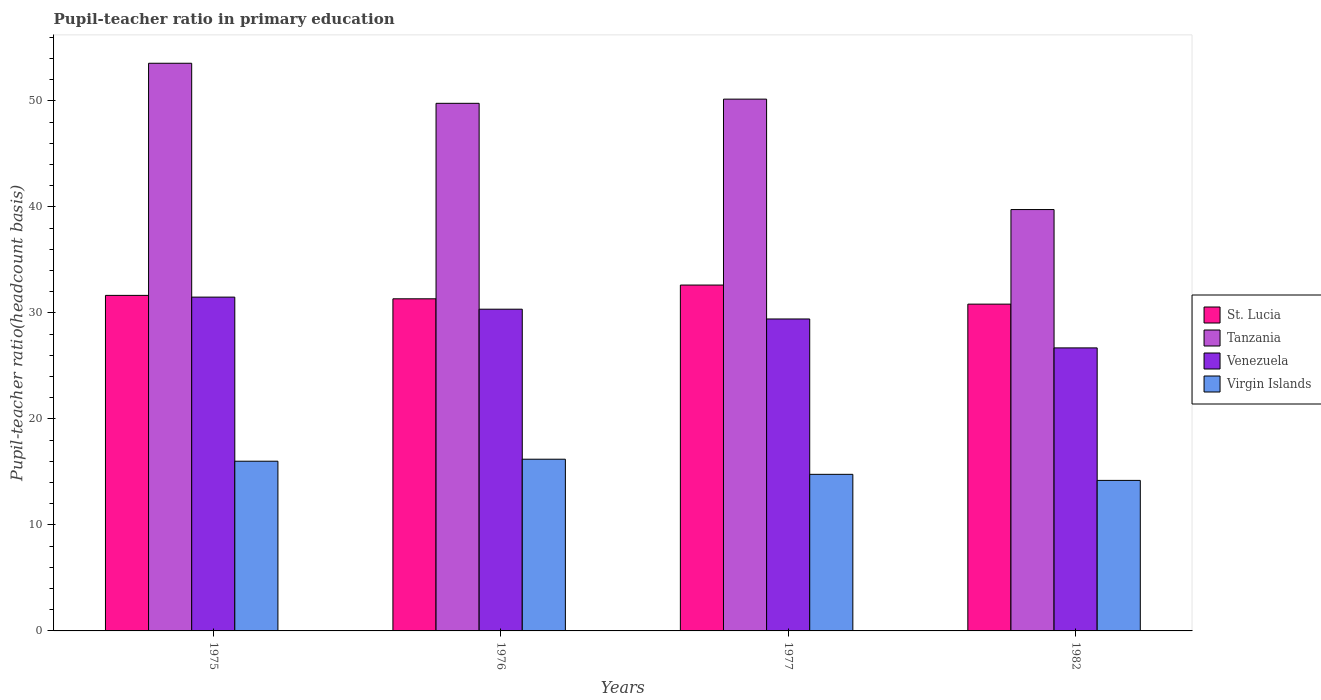How many groups of bars are there?
Ensure brevity in your answer.  4. Are the number of bars per tick equal to the number of legend labels?
Your answer should be very brief. Yes. How many bars are there on the 2nd tick from the right?
Ensure brevity in your answer.  4. What is the label of the 4th group of bars from the left?
Provide a short and direct response. 1982. In how many cases, is the number of bars for a given year not equal to the number of legend labels?
Give a very brief answer. 0. What is the pupil-teacher ratio in primary education in Virgin Islands in 1976?
Ensure brevity in your answer.  16.2. Across all years, what is the maximum pupil-teacher ratio in primary education in St. Lucia?
Offer a very short reply. 32.63. Across all years, what is the minimum pupil-teacher ratio in primary education in St. Lucia?
Offer a terse response. 30.83. In which year was the pupil-teacher ratio in primary education in Venezuela maximum?
Offer a terse response. 1975. What is the total pupil-teacher ratio in primary education in Tanzania in the graph?
Your answer should be compact. 193.25. What is the difference between the pupil-teacher ratio in primary education in Virgin Islands in 1977 and that in 1982?
Give a very brief answer. 0.57. What is the difference between the pupil-teacher ratio in primary education in Tanzania in 1975 and the pupil-teacher ratio in primary education in St. Lucia in 1977?
Your answer should be very brief. 20.92. What is the average pupil-teacher ratio in primary education in Tanzania per year?
Provide a succinct answer. 48.31. In the year 1976, what is the difference between the pupil-teacher ratio in primary education in Virgin Islands and pupil-teacher ratio in primary education in Venezuela?
Your answer should be compact. -14.15. What is the ratio of the pupil-teacher ratio in primary education in Tanzania in 1977 to that in 1982?
Offer a terse response. 1.26. Is the difference between the pupil-teacher ratio in primary education in Virgin Islands in 1975 and 1977 greater than the difference between the pupil-teacher ratio in primary education in Venezuela in 1975 and 1977?
Make the answer very short. No. What is the difference between the highest and the second highest pupil-teacher ratio in primary education in Tanzania?
Keep it short and to the point. 3.38. What is the difference between the highest and the lowest pupil-teacher ratio in primary education in Tanzania?
Your response must be concise. 13.8. What does the 2nd bar from the left in 1977 represents?
Offer a terse response. Tanzania. What does the 2nd bar from the right in 1977 represents?
Provide a short and direct response. Venezuela. Is it the case that in every year, the sum of the pupil-teacher ratio in primary education in Virgin Islands and pupil-teacher ratio in primary education in Tanzania is greater than the pupil-teacher ratio in primary education in Venezuela?
Your response must be concise. Yes. How many bars are there?
Make the answer very short. 16. Are all the bars in the graph horizontal?
Provide a succinct answer. No. How many years are there in the graph?
Your answer should be very brief. 4. What is the difference between two consecutive major ticks on the Y-axis?
Your response must be concise. 10. Are the values on the major ticks of Y-axis written in scientific E-notation?
Keep it short and to the point. No. Does the graph contain any zero values?
Offer a very short reply. No. How many legend labels are there?
Offer a terse response. 4. What is the title of the graph?
Provide a short and direct response. Pupil-teacher ratio in primary education. What is the label or title of the Y-axis?
Your answer should be compact. Pupil-teacher ratio(headcount basis). What is the Pupil-teacher ratio(headcount basis) of St. Lucia in 1975?
Your answer should be very brief. 31.65. What is the Pupil-teacher ratio(headcount basis) of Tanzania in 1975?
Your answer should be compact. 53.55. What is the Pupil-teacher ratio(headcount basis) in Venezuela in 1975?
Ensure brevity in your answer.  31.49. What is the Pupil-teacher ratio(headcount basis) in Virgin Islands in 1975?
Provide a succinct answer. 16.01. What is the Pupil-teacher ratio(headcount basis) of St. Lucia in 1976?
Keep it short and to the point. 31.33. What is the Pupil-teacher ratio(headcount basis) in Tanzania in 1976?
Provide a succinct answer. 49.77. What is the Pupil-teacher ratio(headcount basis) of Venezuela in 1976?
Your answer should be compact. 30.35. What is the Pupil-teacher ratio(headcount basis) of Virgin Islands in 1976?
Offer a terse response. 16.2. What is the Pupil-teacher ratio(headcount basis) of St. Lucia in 1977?
Your answer should be compact. 32.63. What is the Pupil-teacher ratio(headcount basis) of Tanzania in 1977?
Ensure brevity in your answer.  50.17. What is the Pupil-teacher ratio(headcount basis) of Venezuela in 1977?
Provide a short and direct response. 29.43. What is the Pupil-teacher ratio(headcount basis) of Virgin Islands in 1977?
Ensure brevity in your answer.  14.77. What is the Pupil-teacher ratio(headcount basis) of St. Lucia in 1982?
Give a very brief answer. 30.83. What is the Pupil-teacher ratio(headcount basis) of Tanzania in 1982?
Your answer should be very brief. 39.75. What is the Pupil-teacher ratio(headcount basis) of Venezuela in 1982?
Provide a succinct answer. 26.7. Across all years, what is the maximum Pupil-teacher ratio(headcount basis) of St. Lucia?
Ensure brevity in your answer.  32.63. Across all years, what is the maximum Pupil-teacher ratio(headcount basis) in Tanzania?
Ensure brevity in your answer.  53.55. Across all years, what is the maximum Pupil-teacher ratio(headcount basis) of Venezuela?
Offer a terse response. 31.49. Across all years, what is the maximum Pupil-teacher ratio(headcount basis) in Virgin Islands?
Offer a terse response. 16.2. Across all years, what is the minimum Pupil-teacher ratio(headcount basis) in St. Lucia?
Ensure brevity in your answer.  30.83. Across all years, what is the minimum Pupil-teacher ratio(headcount basis) in Tanzania?
Ensure brevity in your answer.  39.75. Across all years, what is the minimum Pupil-teacher ratio(headcount basis) in Venezuela?
Keep it short and to the point. 26.7. Across all years, what is the minimum Pupil-teacher ratio(headcount basis) in Virgin Islands?
Provide a short and direct response. 14.2. What is the total Pupil-teacher ratio(headcount basis) in St. Lucia in the graph?
Keep it short and to the point. 126.44. What is the total Pupil-teacher ratio(headcount basis) in Tanzania in the graph?
Give a very brief answer. 193.25. What is the total Pupil-teacher ratio(headcount basis) in Venezuela in the graph?
Provide a succinct answer. 117.97. What is the total Pupil-teacher ratio(headcount basis) of Virgin Islands in the graph?
Your answer should be very brief. 61.18. What is the difference between the Pupil-teacher ratio(headcount basis) of St. Lucia in 1975 and that in 1976?
Provide a short and direct response. 0.32. What is the difference between the Pupil-teacher ratio(headcount basis) of Tanzania in 1975 and that in 1976?
Make the answer very short. 3.78. What is the difference between the Pupil-teacher ratio(headcount basis) of Venezuela in 1975 and that in 1976?
Your answer should be compact. 1.14. What is the difference between the Pupil-teacher ratio(headcount basis) of Virgin Islands in 1975 and that in 1976?
Offer a very short reply. -0.19. What is the difference between the Pupil-teacher ratio(headcount basis) in St. Lucia in 1975 and that in 1977?
Offer a terse response. -0.97. What is the difference between the Pupil-teacher ratio(headcount basis) in Tanzania in 1975 and that in 1977?
Keep it short and to the point. 3.38. What is the difference between the Pupil-teacher ratio(headcount basis) in Venezuela in 1975 and that in 1977?
Keep it short and to the point. 2.06. What is the difference between the Pupil-teacher ratio(headcount basis) of Virgin Islands in 1975 and that in 1977?
Your answer should be very brief. 1.24. What is the difference between the Pupil-teacher ratio(headcount basis) of St. Lucia in 1975 and that in 1982?
Make the answer very short. 0.82. What is the difference between the Pupil-teacher ratio(headcount basis) of Tanzania in 1975 and that in 1982?
Provide a succinct answer. 13.8. What is the difference between the Pupil-teacher ratio(headcount basis) of Venezuela in 1975 and that in 1982?
Offer a very short reply. 4.79. What is the difference between the Pupil-teacher ratio(headcount basis) of Virgin Islands in 1975 and that in 1982?
Provide a short and direct response. 1.81. What is the difference between the Pupil-teacher ratio(headcount basis) in St. Lucia in 1976 and that in 1977?
Your response must be concise. -1.3. What is the difference between the Pupil-teacher ratio(headcount basis) of Tanzania in 1976 and that in 1977?
Make the answer very short. -0.4. What is the difference between the Pupil-teacher ratio(headcount basis) of Venezuela in 1976 and that in 1977?
Your response must be concise. 0.92. What is the difference between the Pupil-teacher ratio(headcount basis) in Virgin Islands in 1976 and that in 1977?
Your answer should be compact. 1.43. What is the difference between the Pupil-teacher ratio(headcount basis) in St. Lucia in 1976 and that in 1982?
Your response must be concise. 0.5. What is the difference between the Pupil-teacher ratio(headcount basis) in Tanzania in 1976 and that in 1982?
Your response must be concise. 10.02. What is the difference between the Pupil-teacher ratio(headcount basis) in Venezuela in 1976 and that in 1982?
Ensure brevity in your answer.  3.65. What is the difference between the Pupil-teacher ratio(headcount basis) of Virgin Islands in 1976 and that in 1982?
Give a very brief answer. 2. What is the difference between the Pupil-teacher ratio(headcount basis) of St. Lucia in 1977 and that in 1982?
Your answer should be compact. 1.8. What is the difference between the Pupil-teacher ratio(headcount basis) in Tanzania in 1977 and that in 1982?
Provide a succinct answer. 10.42. What is the difference between the Pupil-teacher ratio(headcount basis) in Venezuela in 1977 and that in 1982?
Give a very brief answer. 2.73. What is the difference between the Pupil-teacher ratio(headcount basis) in Virgin Islands in 1977 and that in 1982?
Offer a terse response. 0.57. What is the difference between the Pupil-teacher ratio(headcount basis) in St. Lucia in 1975 and the Pupil-teacher ratio(headcount basis) in Tanzania in 1976?
Ensure brevity in your answer.  -18.12. What is the difference between the Pupil-teacher ratio(headcount basis) of St. Lucia in 1975 and the Pupil-teacher ratio(headcount basis) of Venezuela in 1976?
Your response must be concise. 1.3. What is the difference between the Pupil-teacher ratio(headcount basis) in St. Lucia in 1975 and the Pupil-teacher ratio(headcount basis) in Virgin Islands in 1976?
Keep it short and to the point. 15.46. What is the difference between the Pupil-teacher ratio(headcount basis) in Tanzania in 1975 and the Pupil-teacher ratio(headcount basis) in Venezuela in 1976?
Keep it short and to the point. 23.2. What is the difference between the Pupil-teacher ratio(headcount basis) in Tanzania in 1975 and the Pupil-teacher ratio(headcount basis) in Virgin Islands in 1976?
Your answer should be very brief. 37.35. What is the difference between the Pupil-teacher ratio(headcount basis) in Venezuela in 1975 and the Pupil-teacher ratio(headcount basis) in Virgin Islands in 1976?
Your answer should be very brief. 15.29. What is the difference between the Pupil-teacher ratio(headcount basis) of St. Lucia in 1975 and the Pupil-teacher ratio(headcount basis) of Tanzania in 1977?
Ensure brevity in your answer.  -18.52. What is the difference between the Pupil-teacher ratio(headcount basis) in St. Lucia in 1975 and the Pupil-teacher ratio(headcount basis) in Venezuela in 1977?
Your answer should be compact. 2.23. What is the difference between the Pupil-teacher ratio(headcount basis) in St. Lucia in 1975 and the Pupil-teacher ratio(headcount basis) in Virgin Islands in 1977?
Offer a very short reply. 16.88. What is the difference between the Pupil-teacher ratio(headcount basis) of Tanzania in 1975 and the Pupil-teacher ratio(headcount basis) of Venezuela in 1977?
Make the answer very short. 24.12. What is the difference between the Pupil-teacher ratio(headcount basis) of Tanzania in 1975 and the Pupil-teacher ratio(headcount basis) of Virgin Islands in 1977?
Provide a succinct answer. 38.78. What is the difference between the Pupil-teacher ratio(headcount basis) of Venezuela in 1975 and the Pupil-teacher ratio(headcount basis) of Virgin Islands in 1977?
Provide a succinct answer. 16.72. What is the difference between the Pupil-teacher ratio(headcount basis) in St. Lucia in 1975 and the Pupil-teacher ratio(headcount basis) in Tanzania in 1982?
Provide a succinct answer. -8.1. What is the difference between the Pupil-teacher ratio(headcount basis) in St. Lucia in 1975 and the Pupil-teacher ratio(headcount basis) in Venezuela in 1982?
Ensure brevity in your answer.  4.95. What is the difference between the Pupil-teacher ratio(headcount basis) in St. Lucia in 1975 and the Pupil-teacher ratio(headcount basis) in Virgin Islands in 1982?
Offer a terse response. 17.45. What is the difference between the Pupil-teacher ratio(headcount basis) in Tanzania in 1975 and the Pupil-teacher ratio(headcount basis) in Venezuela in 1982?
Offer a very short reply. 26.85. What is the difference between the Pupil-teacher ratio(headcount basis) of Tanzania in 1975 and the Pupil-teacher ratio(headcount basis) of Virgin Islands in 1982?
Offer a terse response. 39.35. What is the difference between the Pupil-teacher ratio(headcount basis) of Venezuela in 1975 and the Pupil-teacher ratio(headcount basis) of Virgin Islands in 1982?
Ensure brevity in your answer.  17.29. What is the difference between the Pupil-teacher ratio(headcount basis) in St. Lucia in 1976 and the Pupil-teacher ratio(headcount basis) in Tanzania in 1977?
Make the answer very short. -18.84. What is the difference between the Pupil-teacher ratio(headcount basis) in St. Lucia in 1976 and the Pupil-teacher ratio(headcount basis) in Venezuela in 1977?
Ensure brevity in your answer.  1.9. What is the difference between the Pupil-teacher ratio(headcount basis) of St. Lucia in 1976 and the Pupil-teacher ratio(headcount basis) of Virgin Islands in 1977?
Keep it short and to the point. 16.56. What is the difference between the Pupil-teacher ratio(headcount basis) of Tanzania in 1976 and the Pupil-teacher ratio(headcount basis) of Venezuela in 1977?
Your answer should be compact. 20.34. What is the difference between the Pupil-teacher ratio(headcount basis) of Tanzania in 1976 and the Pupil-teacher ratio(headcount basis) of Virgin Islands in 1977?
Keep it short and to the point. 35. What is the difference between the Pupil-teacher ratio(headcount basis) in Venezuela in 1976 and the Pupil-teacher ratio(headcount basis) in Virgin Islands in 1977?
Give a very brief answer. 15.58. What is the difference between the Pupil-teacher ratio(headcount basis) of St. Lucia in 1976 and the Pupil-teacher ratio(headcount basis) of Tanzania in 1982?
Offer a terse response. -8.42. What is the difference between the Pupil-teacher ratio(headcount basis) of St. Lucia in 1976 and the Pupil-teacher ratio(headcount basis) of Venezuela in 1982?
Give a very brief answer. 4.63. What is the difference between the Pupil-teacher ratio(headcount basis) of St. Lucia in 1976 and the Pupil-teacher ratio(headcount basis) of Virgin Islands in 1982?
Your response must be concise. 17.13. What is the difference between the Pupil-teacher ratio(headcount basis) of Tanzania in 1976 and the Pupil-teacher ratio(headcount basis) of Venezuela in 1982?
Give a very brief answer. 23.07. What is the difference between the Pupil-teacher ratio(headcount basis) of Tanzania in 1976 and the Pupil-teacher ratio(headcount basis) of Virgin Islands in 1982?
Offer a very short reply. 35.57. What is the difference between the Pupil-teacher ratio(headcount basis) of Venezuela in 1976 and the Pupil-teacher ratio(headcount basis) of Virgin Islands in 1982?
Provide a short and direct response. 16.15. What is the difference between the Pupil-teacher ratio(headcount basis) in St. Lucia in 1977 and the Pupil-teacher ratio(headcount basis) in Tanzania in 1982?
Provide a succinct answer. -7.12. What is the difference between the Pupil-teacher ratio(headcount basis) of St. Lucia in 1977 and the Pupil-teacher ratio(headcount basis) of Venezuela in 1982?
Offer a terse response. 5.93. What is the difference between the Pupil-teacher ratio(headcount basis) of St. Lucia in 1977 and the Pupil-teacher ratio(headcount basis) of Virgin Islands in 1982?
Your answer should be compact. 18.43. What is the difference between the Pupil-teacher ratio(headcount basis) of Tanzania in 1977 and the Pupil-teacher ratio(headcount basis) of Venezuela in 1982?
Your answer should be very brief. 23.47. What is the difference between the Pupil-teacher ratio(headcount basis) in Tanzania in 1977 and the Pupil-teacher ratio(headcount basis) in Virgin Islands in 1982?
Keep it short and to the point. 35.97. What is the difference between the Pupil-teacher ratio(headcount basis) in Venezuela in 1977 and the Pupil-teacher ratio(headcount basis) in Virgin Islands in 1982?
Offer a very short reply. 15.23. What is the average Pupil-teacher ratio(headcount basis) in St. Lucia per year?
Offer a very short reply. 31.61. What is the average Pupil-teacher ratio(headcount basis) in Tanzania per year?
Offer a very short reply. 48.31. What is the average Pupil-teacher ratio(headcount basis) of Venezuela per year?
Your answer should be very brief. 29.49. What is the average Pupil-teacher ratio(headcount basis) of Virgin Islands per year?
Your answer should be very brief. 15.3. In the year 1975, what is the difference between the Pupil-teacher ratio(headcount basis) of St. Lucia and Pupil-teacher ratio(headcount basis) of Tanzania?
Make the answer very short. -21.9. In the year 1975, what is the difference between the Pupil-teacher ratio(headcount basis) in St. Lucia and Pupil-teacher ratio(headcount basis) in Venezuela?
Provide a succinct answer. 0.16. In the year 1975, what is the difference between the Pupil-teacher ratio(headcount basis) of St. Lucia and Pupil-teacher ratio(headcount basis) of Virgin Islands?
Provide a succinct answer. 15.64. In the year 1975, what is the difference between the Pupil-teacher ratio(headcount basis) in Tanzania and Pupil-teacher ratio(headcount basis) in Venezuela?
Offer a terse response. 22.06. In the year 1975, what is the difference between the Pupil-teacher ratio(headcount basis) in Tanzania and Pupil-teacher ratio(headcount basis) in Virgin Islands?
Provide a succinct answer. 37.54. In the year 1975, what is the difference between the Pupil-teacher ratio(headcount basis) in Venezuela and Pupil-teacher ratio(headcount basis) in Virgin Islands?
Your response must be concise. 15.48. In the year 1976, what is the difference between the Pupil-teacher ratio(headcount basis) in St. Lucia and Pupil-teacher ratio(headcount basis) in Tanzania?
Provide a short and direct response. -18.44. In the year 1976, what is the difference between the Pupil-teacher ratio(headcount basis) of St. Lucia and Pupil-teacher ratio(headcount basis) of Venezuela?
Provide a short and direct response. 0.98. In the year 1976, what is the difference between the Pupil-teacher ratio(headcount basis) of St. Lucia and Pupil-teacher ratio(headcount basis) of Virgin Islands?
Your response must be concise. 15.13. In the year 1976, what is the difference between the Pupil-teacher ratio(headcount basis) of Tanzania and Pupil-teacher ratio(headcount basis) of Venezuela?
Your answer should be compact. 19.42. In the year 1976, what is the difference between the Pupil-teacher ratio(headcount basis) in Tanzania and Pupil-teacher ratio(headcount basis) in Virgin Islands?
Offer a very short reply. 33.57. In the year 1976, what is the difference between the Pupil-teacher ratio(headcount basis) of Venezuela and Pupil-teacher ratio(headcount basis) of Virgin Islands?
Ensure brevity in your answer.  14.15. In the year 1977, what is the difference between the Pupil-teacher ratio(headcount basis) of St. Lucia and Pupil-teacher ratio(headcount basis) of Tanzania?
Give a very brief answer. -17.54. In the year 1977, what is the difference between the Pupil-teacher ratio(headcount basis) in St. Lucia and Pupil-teacher ratio(headcount basis) in Venezuela?
Your answer should be very brief. 3.2. In the year 1977, what is the difference between the Pupil-teacher ratio(headcount basis) in St. Lucia and Pupil-teacher ratio(headcount basis) in Virgin Islands?
Give a very brief answer. 17.86. In the year 1977, what is the difference between the Pupil-teacher ratio(headcount basis) in Tanzania and Pupil-teacher ratio(headcount basis) in Venezuela?
Offer a terse response. 20.74. In the year 1977, what is the difference between the Pupil-teacher ratio(headcount basis) of Tanzania and Pupil-teacher ratio(headcount basis) of Virgin Islands?
Make the answer very short. 35.4. In the year 1977, what is the difference between the Pupil-teacher ratio(headcount basis) in Venezuela and Pupil-teacher ratio(headcount basis) in Virgin Islands?
Offer a very short reply. 14.66. In the year 1982, what is the difference between the Pupil-teacher ratio(headcount basis) of St. Lucia and Pupil-teacher ratio(headcount basis) of Tanzania?
Ensure brevity in your answer.  -8.92. In the year 1982, what is the difference between the Pupil-teacher ratio(headcount basis) in St. Lucia and Pupil-teacher ratio(headcount basis) in Venezuela?
Offer a terse response. 4.13. In the year 1982, what is the difference between the Pupil-teacher ratio(headcount basis) of St. Lucia and Pupil-teacher ratio(headcount basis) of Virgin Islands?
Keep it short and to the point. 16.63. In the year 1982, what is the difference between the Pupil-teacher ratio(headcount basis) in Tanzania and Pupil-teacher ratio(headcount basis) in Venezuela?
Your response must be concise. 13.05. In the year 1982, what is the difference between the Pupil-teacher ratio(headcount basis) of Tanzania and Pupil-teacher ratio(headcount basis) of Virgin Islands?
Offer a terse response. 25.55. In the year 1982, what is the difference between the Pupil-teacher ratio(headcount basis) in Venezuela and Pupil-teacher ratio(headcount basis) in Virgin Islands?
Give a very brief answer. 12.5. What is the ratio of the Pupil-teacher ratio(headcount basis) in St. Lucia in 1975 to that in 1976?
Make the answer very short. 1.01. What is the ratio of the Pupil-teacher ratio(headcount basis) of Tanzania in 1975 to that in 1976?
Provide a succinct answer. 1.08. What is the ratio of the Pupil-teacher ratio(headcount basis) of Venezuela in 1975 to that in 1976?
Offer a terse response. 1.04. What is the ratio of the Pupil-teacher ratio(headcount basis) in Virgin Islands in 1975 to that in 1976?
Offer a terse response. 0.99. What is the ratio of the Pupil-teacher ratio(headcount basis) of St. Lucia in 1975 to that in 1977?
Make the answer very short. 0.97. What is the ratio of the Pupil-teacher ratio(headcount basis) of Tanzania in 1975 to that in 1977?
Provide a succinct answer. 1.07. What is the ratio of the Pupil-teacher ratio(headcount basis) in Venezuela in 1975 to that in 1977?
Your response must be concise. 1.07. What is the ratio of the Pupil-teacher ratio(headcount basis) of Virgin Islands in 1975 to that in 1977?
Give a very brief answer. 1.08. What is the ratio of the Pupil-teacher ratio(headcount basis) in St. Lucia in 1975 to that in 1982?
Ensure brevity in your answer.  1.03. What is the ratio of the Pupil-teacher ratio(headcount basis) of Tanzania in 1975 to that in 1982?
Your answer should be very brief. 1.35. What is the ratio of the Pupil-teacher ratio(headcount basis) of Venezuela in 1975 to that in 1982?
Your answer should be compact. 1.18. What is the ratio of the Pupil-teacher ratio(headcount basis) in Virgin Islands in 1975 to that in 1982?
Your response must be concise. 1.13. What is the ratio of the Pupil-teacher ratio(headcount basis) in St. Lucia in 1976 to that in 1977?
Offer a very short reply. 0.96. What is the ratio of the Pupil-teacher ratio(headcount basis) of Tanzania in 1976 to that in 1977?
Provide a succinct answer. 0.99. What is the ratio of the Pupil-teacher ratio(headcount basis) in Venezuela in 1976 to that in 1977?
Ensure brevity in your answer.  1.03. What is the ratio of the Pupil-teacher ratio(headcount basis) in Virgin Islands in 1976 to that in 1977?
Your answer should be very brief. 1.1. What is the ratio of the Pupil-teacher ratio(headcount basis) of St. Lucia in 1976 to that in 1982?
Keep it short and to the point. 1.02. What is the ratio of the Pupil-teacher ratio(headcount basis) of Tanzania in 1976 to that in 1982?
Offer a very short reply. 1.25. What is the ratio of the Pupil-teacher ratio(headcount basis) in Venezuela in 1976 to that in 1982?
Give a very brief answer. 1.14. What is the ratio of the Pupil-teacher ratio(headcount basis) of Virgin Islands in 1976 to that in 1982?
Provide a short and direct response. 1.14. What is the ratio of the Pupil-teacher ratio(headcount basis) of St. Lucia in 1977 to that in 1982?
Your response must be concise. 1.06. What is the ratio of the Pupil-teacher ratio(headcount basis) of Tanzania in 1977 to that in 1982?
Offer a terse response. 1.26. What is the ratio of the Pupil-teacher ratio(headcount basis) of Venezuela in 1977 to that in 1982?
Make the answer very short. 1.1. What is the ratio of the Pupil-teacher ratio(headcount basis) in Virgin Islands in 1977 to that in 1982?
Ensure brevity in your answer.  1.04. What is the difference between the highest and the second highest Pupil-teacher ratio(headcount basis) of St. Lucia?
Offer a terse response. 0.97. What is the difference between the highest and the second highest Pupil-teacher ratio(headcount basis) of Tanzania?
Your answer should be very brief. 3.38. What is the difference between the highest and the second highest Pupil-teacher ratio(headcount basis) in Venezuela?
Your response must be concise. 1.14. What is the difference between the highest and the second highest Pupil-teacher ratio(headcount basis) in Virgin Islands?
Your response must be concise. 0.19. What is the difference between the highest and the lowest Pupil-teacher ratio(headcount basis) of St. Lucia?
Make the answer very short. 1.8. What is the difference between the highest and the lowest Pupil-teacher ratio(headcount basis) of Tanzania?
Provide a short and direct response. 13.8. What is the difference between the highest and the lowest Pupil-teacher ratio(headcount basis) in Venezuela?
Ensure brevity in your answer.  4.79. What is the difference between the highest and the lowest Pupil-teacher ratio(headcount basis) of Virgin Islands?
Your answer should be very brief. 2. 